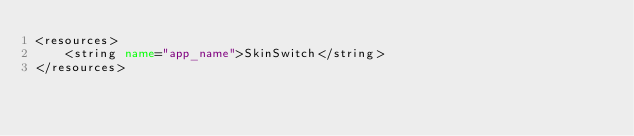<code> <loc_0><loc_0><loc_500><loc_500><_XML_><resources>
    <string name="app_name">SkinSwitch</string>
</resources>
</code> 